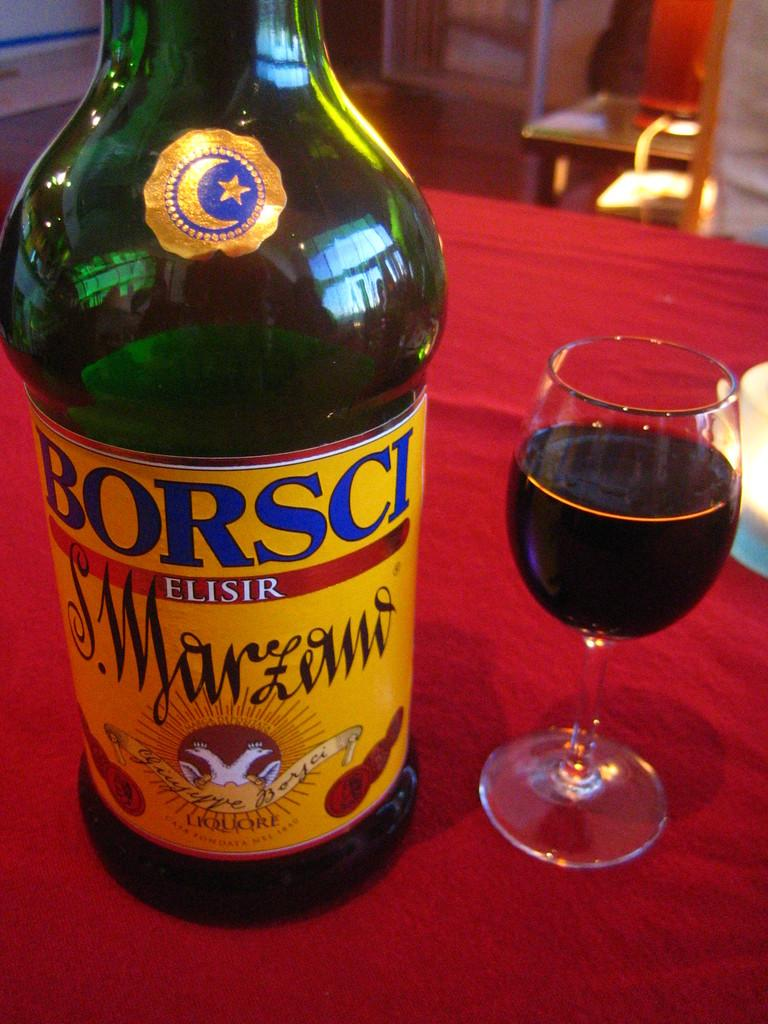<image>
Describe the image concisely. A bottle of Borsci Elisir is on a table next to a wine glass. 